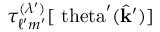Convert formula to latex. <formula><loc_0><loc_0><loc_500><loc_500>\tau _ { \ell ^ { \prime } m ^ { \prime } } ^ { ( \lambda ^ { \prime } ) } [ \ t h e t a ^ { \prime } ( \hat { k } ^ { \prime } ) ]</formula> 